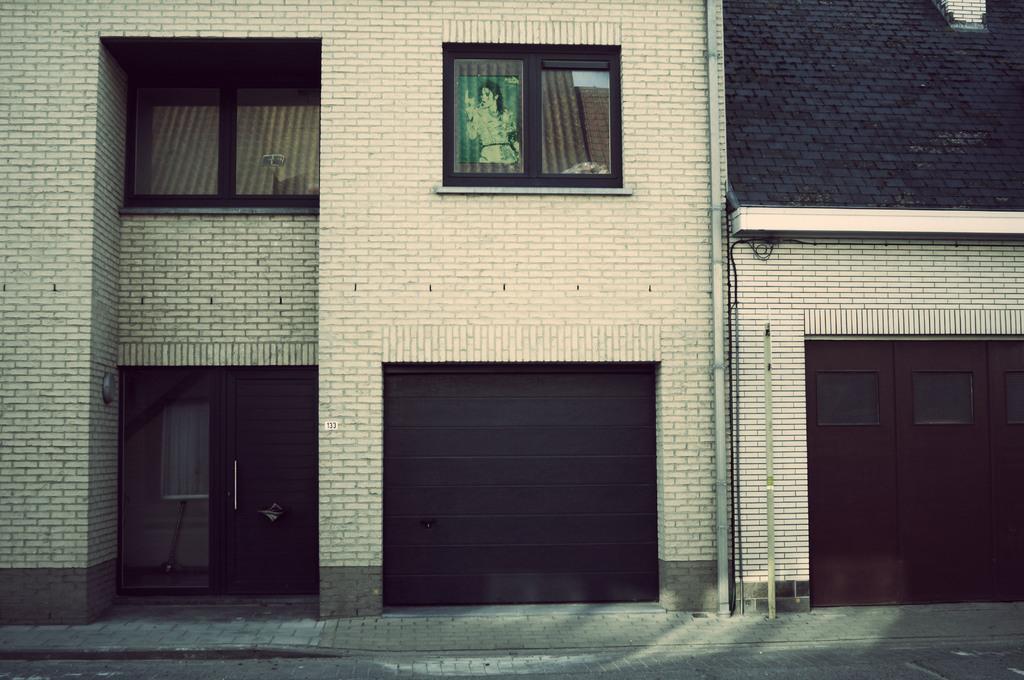Can you describe this image briefly? In the picture we can see a building wall which is constructed with a brick which are cream in color and to the walls we can see some windows with a glass and to the wall we can see some pipe. 